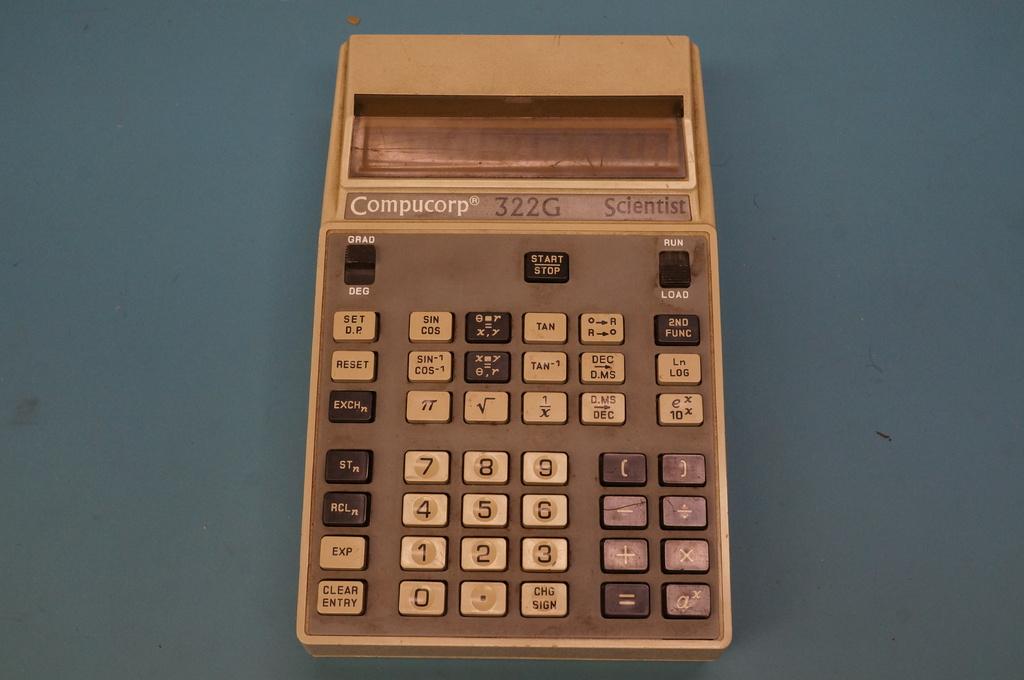What number is above the "5" key?
Make the answer very short. 8. Which calculater it is?
Keep it short and to the point. Compucorp. 